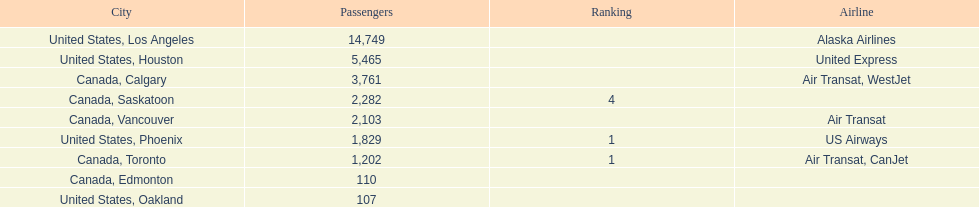How many cities from canada are on this list? 5. 